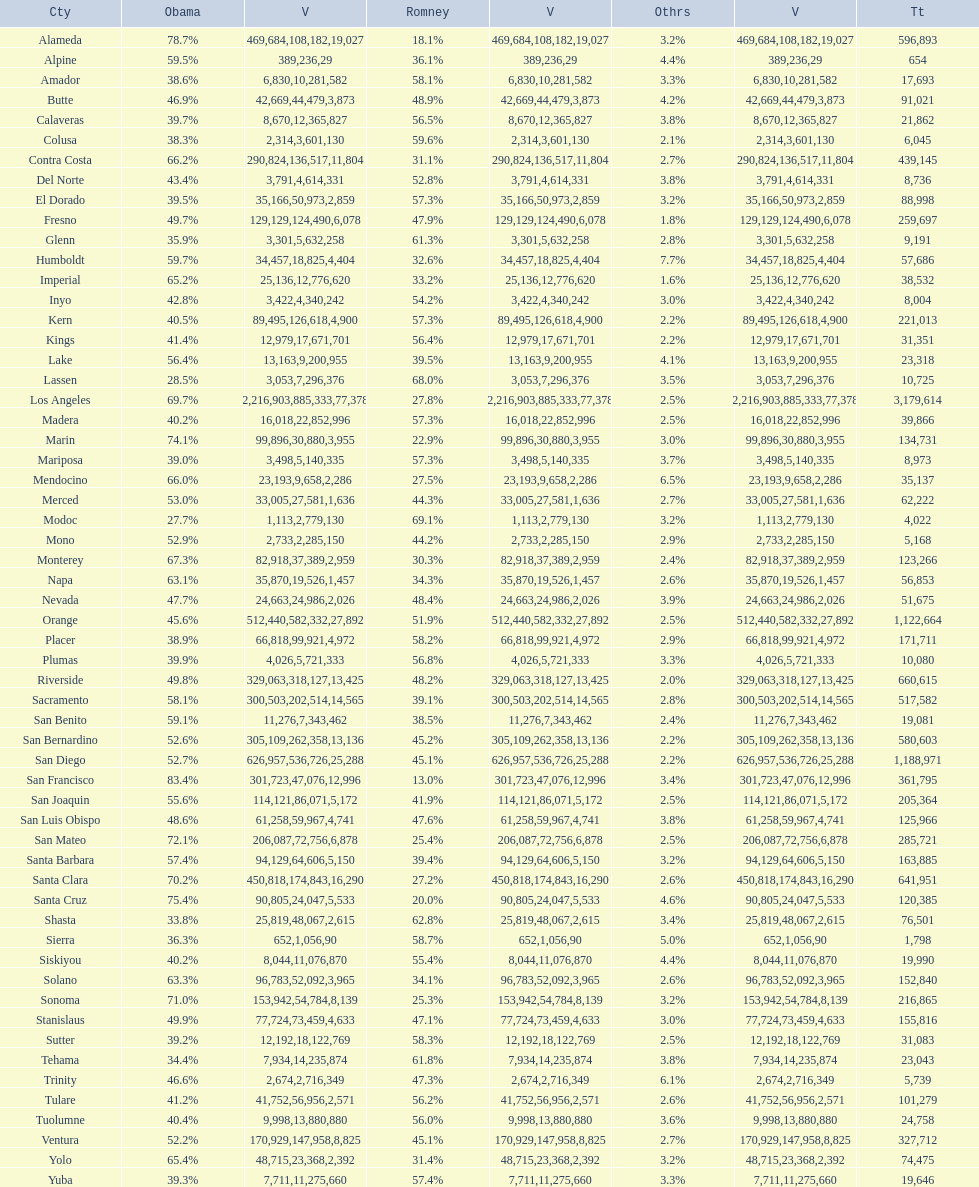Which county had the lower percentage votes for obama: amador, humboldt, or lake? Amador. 